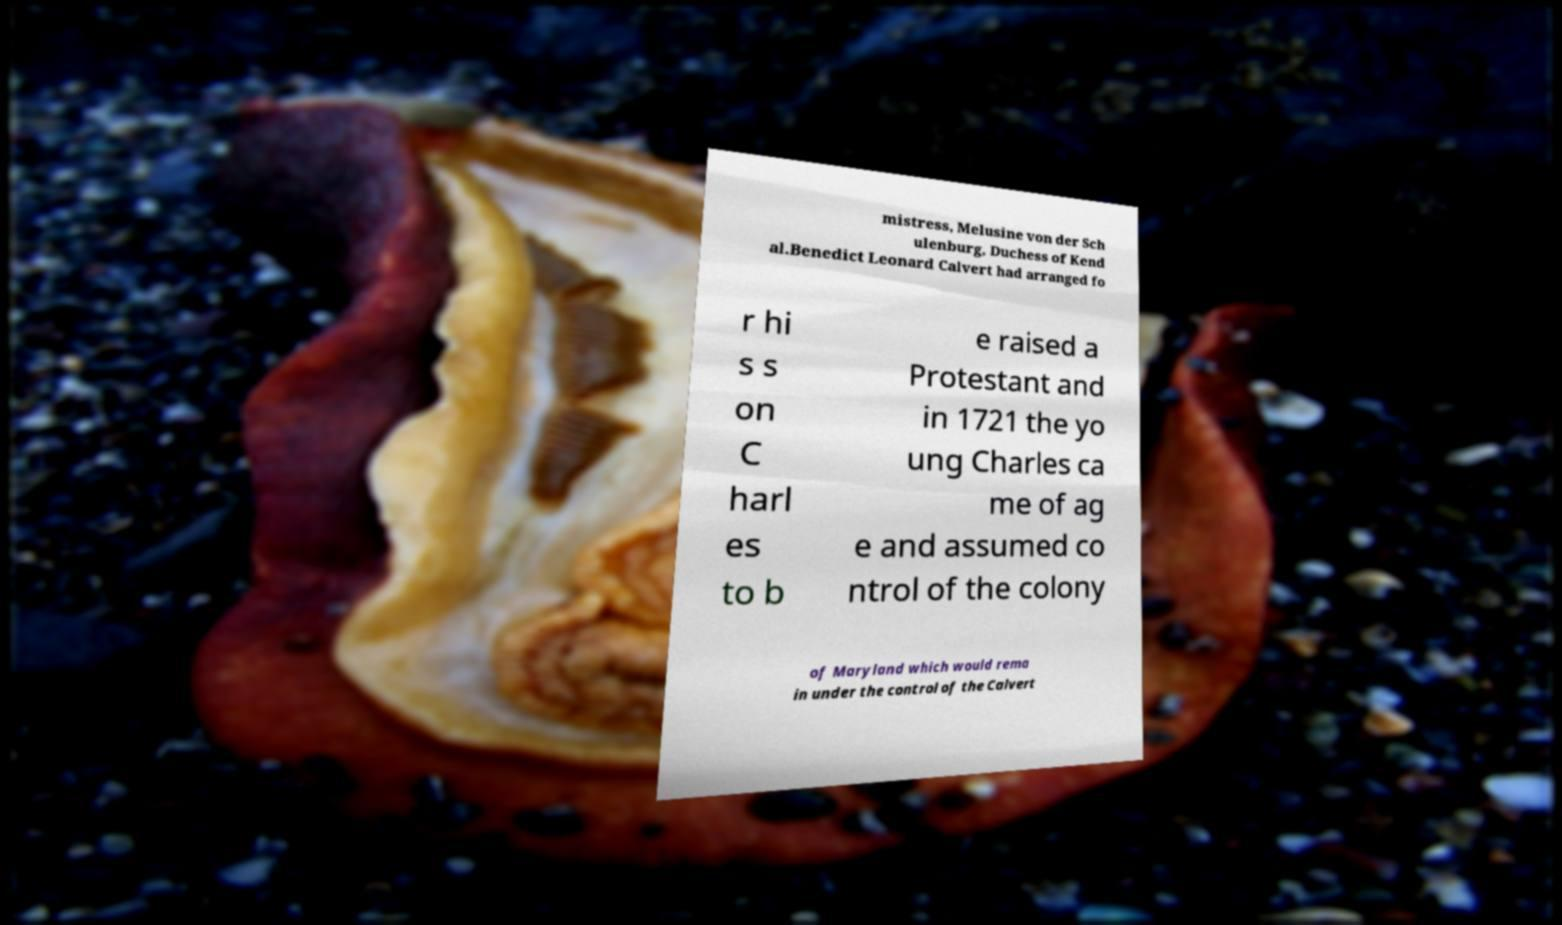Please read and relay the text visible in this image. What does it say? mistress, Melusine von der Sch ulenburg, Duchess of Kend al.Benedict Leonard Calvert had arranged fo r hi s s on C harl es to b e raised a Protestant and in 1721 the yo ung Charles ca me of ag e and assumed co ntrol of the colony of Maryland which would rema in under the control of the Calvert 